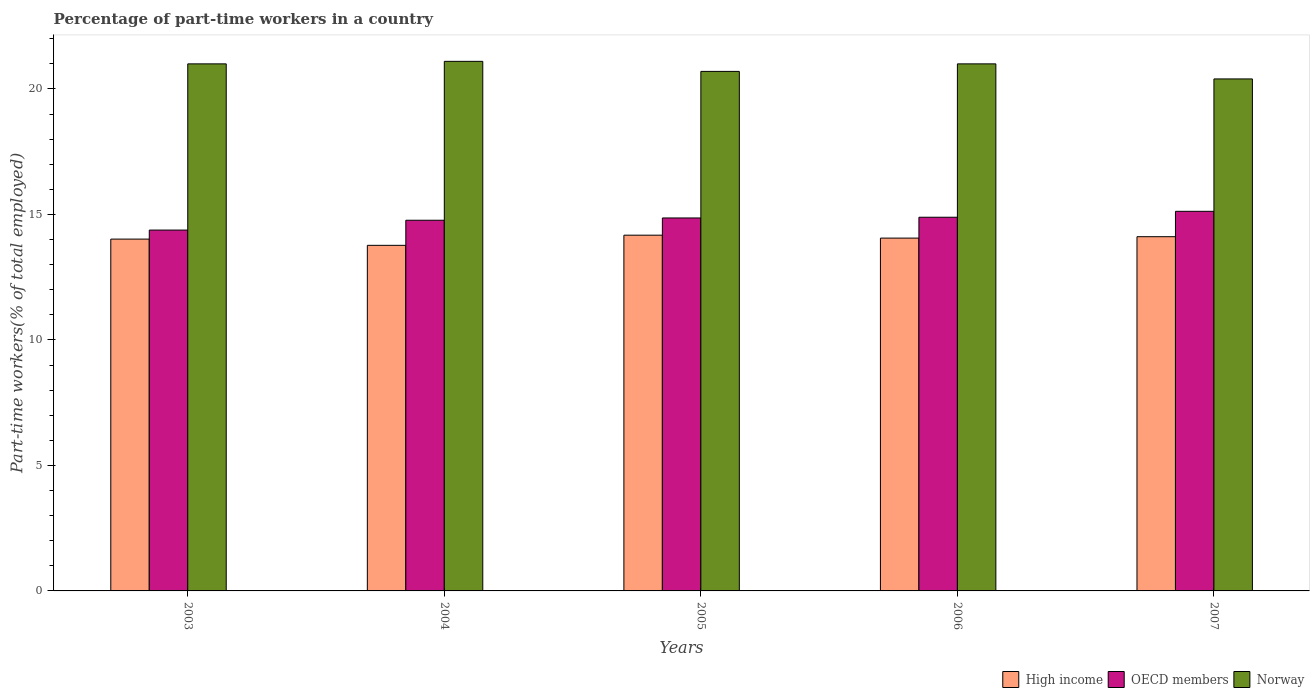How many different coloured bars are there?
Provide a short and direct response. 3. Are the number of bars per tick equal to the number of legend labels?
Offer a terse response. Yes. How many bars are there on the 5th tick from the right?
Your response must be concise. 3. What is the label of the 4th group of bars from the left?
Your response must be concise. 2006. Across all years, what is the maximum percentage of part-time workers in Norway?
Offer a very short reply. 21.1. Across all years, what is the minimum percentage of part-time workers in Norway?
Provide a short and direct response. 20.4. In which year was the percentage of part-time workers in Norway maximum?
Offer a very short reply. 2004. In which year was the percentage of part-time workers in Norway minimum?
Offer a terse response. 2007. What is the total percentage of part-time workers in Norway in the graph?
Offer a very short reply. 104.2. What is the difference between the percentage of part-time workers in Norway in 2005 and that in 2007?
Ensure brevity in your answer.  0.3. What is the difference between the percentage of part-time workers in High income in 2006 and the percentage of part-time workers in OECD members in 2004?
Provide a short and direct response. -0.71. What is the average percentage of part-time workers in High income per year?
Provide a succinct answer. 14.03. In the year 2007, what is the difference between the percentage of part-time workers in Norway and percentage of part-time workers in High income?
Your response must be concise. 6.29. What is the ratio of the percentage of part-time workers in High income in 2003 to that in 2007?
Provide a succinct answer. 0.99. Is the percentage of part-time workers in Norway in 2004 less than that in 2006?
Your response must be concise. No. What is the difference between the highest and the second highest percentage of part-time workers in OECD members?
Make the answer very short. 0.24. What is the difference between the highest and the lowest percentage of part-time workers in OECD members?
Offer a very short reply. 0.75. In how many years, is the percentage of part-time workers in OECD members greater than the average percentage of part-time workers in OECD members taken over all years?
Give a very brief answer. 3. Is the sum of the percentage of part-time workers in Norway in 2005 and 2007 greater than the maximum percentage of part-time workers in OECD members across all years?
Make the answer very short. Yes. What does the 2nd bar from the left in 2006 represents?
Your response must be concise. OECD members. Are all the bars in the graph horizontal?
Your answer should be very brief. No. How many years are there in the graph?
Provide a succinct answer. 5. Are the values on the major ticks of Y-axis written in scientific E-notation?
Your answer should be very brief. No. Does the graph contain grids?
Give a very brief answer. No. Where does the legend appear in the graph?
Give a very brief answer. Bottom right. How many legend labels are there?
Offer a terse response. 3. How are the legend labels stacked?
Give a very brief answer. Horizontal. What is the title of the graph?
Make the answer very short. Percentage of part-time workers in a country. Does "Hong Kong" appear as one of the legend labels in the graph?
Ensure brevity in your answer.  No. What is the label or title of the X-axis?
Offer a terse response. Years. What is the label or title of the Y-axis?
Give a very brief answer. Part-time workers(% of total employed). What is the Part-time workers(% of total employed) in High income in 2003?
Your answer should be compact. 14.02. What is the Part-time workers(% of total employed) of OECD members in 2003?
Provide a short and direct response. 14.38. What is the Part-time workers(% of total employed) in Norway in 2003?
Your response must be concise. 21. What is the Part-time workers(% of total employed) of High income in 2004?
Give a very brief answer. 13.77. What is the Part-time workers(% of total employed) of OECD members in 2004?
Ensure brevity in your answer.  14.77. What is the Part-time workers(% of total employed) of Norway in 2004?
Your answer should be compact. 21.1. What is the Part-time workers(% of total employed) of High income in 2005?
Your response must be concise. 14.17. What is the Part-time workers(% of total employed) of OECD members in 2005?
Keep it short and to the point. 14.86. What is the Part-time workers(% of total employed) of Norway in 2005?
Ensure brevity in your answer.  20.7. What is the Part-time workers(% of total employed) of High income in 2006?
Ensure brevity in your answer.  14.06. What is the Part-time workers(% of total employed) in OECD members in 2006?
Make the answer very short. 14.89. What is the Part-time workers(% of total employed) in Norway in 2006?
Ensure brevity in your answer.  21. What is the Part-time workers(% of total employed) of High income in 2007?
Your response must be concise. 14.11. What is the Part-time workers(% of total employed) in OECD members in 2007?
Your answer should be compact. 15.12. What is the Part-time workers(% of total employed) in Norway in 2007?
Give a very brief answer. 20.4. Across all years, what is the maximum Part-time workers(% of total employed) of High income?
Provide a short and direct response. 14.17. Across all years, what is the maximum Part-time workers(% of total employed) in OECD members?
Offer a terse response. 15.12. Across all years, what is the maximum Part-time workers(% of total employed) of Norway?
Keep it short and to the point. 21.1. Across all years, what is the minimum Part-time workers(% of total employed) in High income?
Provide a succinct answer. 13.77. Across all years, what is the minimum Part-time workers(% of total employed) in OECD members?
Provide a succinct answer. 14.38. Across all years, what is the minimum Part-time workers(% of total employed) in Norway?
Ensure brevity in your answer.  20.4. What is the total Part-time workers(% of total employed) of High income in the graph?
Provide a succinct answer. 70.13. What is the total Part-time workers(% of total employed) of OECD members in the graph?
Your answer should be compact. 74.02. What is the total Part-time workers(% of total employed) in Norway in the graph?
Offer a very short reply. 104.2. What is the difference between the Part-time workers(% of total employed) in High income in 2003 and that in 2004?
Make the answer very short. 0.25. What is the difference between the Part-time workers(% of total employed) in OECD members in 2003 and that in 2004?
Give a very brief answer. -0.39. What is the difference between the Part-time workers(% of total employed) in Norway in 2003 and that in 2004?
Make the answer very short. -0.1. What is the difference between the Part-time workers(% of total employed) of High income in 2003 and that in 2005?
Ensure brevity in your answer.  -0.16. What is the difference between the Part-time workers(% of total employed) in OECD members in 2003 and that in 2005?
Make the answer very short. -0.48. What is the difference between the Part-time workers(% of total employed) in Norway in 2003 and that in 2005?
Your answer should be compact. 0.3. What is the difference between the Part-time workers(% of total employed) of High income in 2003 and that in 2006?
Keep it short and to the point. -0.04. What is the difference between the Part-time workers(% of total employed) of OECD members in 2003 and that in 2006?
Keep it short and to the point. -0.51. What is the difference between the Part-time workers(% of total employed) of Norway in 2003 and that in 2006?
Offer a very short reply. 0. What is the difference between the Part-time workers(% of total employed) of High income in 2003 and that in 2007?
Keep it short and to the point. -0.1. What is the difference between the Part-time workers(% of total employed) of OECD members in 2003 and that in 2007?
Ensure brevity in your answer.  -0.75. What is the difference between the Part-time workers(% of total employed) in Norway in 2003 and that in 2007?
Your answer should be compact. 0.6. What is the difference between the Part-time workers(% of total employed) in High income in 2004 and that in 2005?
Keep it short and to the point. -0.4. What is the difference between the Part-time workers(% of total employed) in OECD members in 2004 and that in 2005?
Your answer should be very brief. -0.09. What is the difference between the Part-time workers(% of total employed) in Norway in 2004 and that in 2005?
Ensure brevity in your answer.  0.4. What is the difference between the Part-time workers(% of total employed) in High income in 2004 and that in 2006?
Keep it short and to the point. -0.29. What is the difference between the Part-time workers(% of total employed) in OECD members in 2004 and that in 2006?
Your response must be concise. -0.12. What is the difference between the Part-time workers(% of total employed) of High income in 2004 and that in 2007?
Your response must be concise. -0.34. What is the difference between the Part-time workers(% of total employed) in OECD members in 2004 and that in 2007?
Provide a short and direct response. -0.36. What is the difference between the Part-time workers(% of total employed) of High income in 2005 and that in 2006?
Make the answer very short. 0.12. What is the difference between the Part-time workers(% of total employed) in OECD members in 2005 and that in 2006?
Make the answer very short. -0.03. What is the difference between the Part-time workers(% of total employed) of Norway in 2005 and that in 2006?
Your answer should be compact. -0.3. What is the difference between the Part-time workers(% of total employed) of High income in 2005 and that in 2007?
Ensure brevity in your answer.  0.06. What is the difference between the Part-time workers(% of total employed) of OECD members in 2005 and that in 2007?
Your response must be concise. -0.26. What is the difference between the Part-time workers(% of total employed) in Norway in 2005 and that in 2007?
Offer a very short reply. 0.3. What is the difference between the Part-time workers(% of total employed) of High income in 2006 and that in 2007?
Make the answer very short. -0.06. What is the difference between the Part-time workers(% of total employed) of OECD members in 2006 and that in 2007?
Make the answer very short. -0.24. What is the difference between the Part-time workers(% of total employed) in Norway in 2006 and that in 2007?
Offer a terse response. 0.6. What is the difference between the Part-time workers(% of total employed) of High income in 2003 and the Part-time workers(% of total employed) of OECD members in 2004?
Offer a very short reply. -0.75. What is the difference between the Part-time workers(% of total employed) of High income in 2003 and the Part-time workers(% of total employed) of Norway in 2004?
Your answer should be very brief. -7.08. What is the difference between the Part-time workers(% of total employed) of OECD members in 2003 and the Part-time workers(% of total employed) of Norway in 2004?
Keep it short and to the point. -6.72. What is the difference between the Part-time workers(% of total employed) in High income in 2003 and the Part-time workers(% of total employed) in OECD members in 2005?
Make the answer very short. -0.84. What is the difference between the Part-time workers(% of total employed) in High income in 2003 and the Part-time workers(% of total employed) in Norway in 2005?
Give a very brief answer. -6.68. What is the difference between the Part-time workers(% of total employed) of OECD members in 2003 and the Part-time workers(% of total employed) of Norway in 2005?
Your answer should be very brief. -6.32. What is the difference between the Part-time workers(% of total employed) in High income in 2003 and the Part-time workers(% of total employed) in OECD members in 2006?
Your response must be concise. -0.87. What is the difference between the Part-time workers(% of total employed) in High income in 2003 and the Part-time workers(% of total employed) in Norway in 2006?
Your response must be concise. -6.98. What is the difference between the Part-time workers(% of total employed) in OECD members in 2003 and the Part-time workers(% of total employed) in Norway in 2006?
Your response must be concise. -6.62. What is the difference between the Part-time workers(% of total employed) of High income in 2003 and the Part-time workers(% of total employed) of OECD members in 2007?
Provide a short and direct response. -1.11. What is the difference between the Part-time workers(% of total employed) of High income in 2003 and the Part-time workers(% of total employed) of Norway in 2007?
Make the answer very short. -6.38. What is the difference between the Part-time workers(% of total employed) in OECD members in 2003 and the Part-time workers(% of total employed) in Norway in 2007?
Provide a succinct answer. -6.02. What is the difference between the Part-time workers(% of total employed) of High income in 2004 and the Part-time workers(% of total employed) of OECD members in 2005?
Keep it short and to the point. -1.09. What is the difference between the Part-time workers(% of total employed) in High income in 2004 and the Part-time workers(% of total employed) in Norway in 2005?
Keep it short and to the point. -6.93. What is the difference between the Part-time workers(% of total employed) of OECD members in 2004 and the Part-time workers(% of total employed) of Norway in 2005?
Provide a short and direct response. -5.93. What is the difference between the Part-time workers(% of total employed) of High income in 2004 and the Part-time workers(% of total employed) of OECD members in 2006?
Ensure brevity in your answer.  -1.12. What is the difference between the Part-time workers(% of total employed) of High income in 2004 and the Part-time workers(% of total employed) of Norway in 2006?
Ensure brevity in your answer.  -7.23. What is the difference between the Part-time workers(% of total employed) of OECD members in 2004 and the Part-time workers(% of total employed) of Norway in 2006?
Ensure brevity in your answer.  -6.23. What is the difference between the Part-time workers(% of total employed) in High income in 2004 and the Part-time workers(% of total employed) in OECD members in 2007?
Keep it short and to the point. -1.36. What is the difference between the Part-time workers(% of total employed) in High income in 2004 and the Part-time workers(% of total employed) in Norway in 2007?
Your response must be concise. -6.63. What is the difference between the Part-time workers(% of total employed) in OECD members in 2004 and the Part-time workers(% of total employed) in Norway in 2007?
Provide a succinct answer. -5.63. What is the difference between the Part-time workers(% of total employed) in High income in 2005 and the Part-time workers(% of total employed) in OECD members in 2006?
Make the answer very short. -0.71. What is the difference between the Part-time workers(% of total employed) of High income in 2005 and the Part-time workers(% of total employed) of Norway in 2006?
Offer a very short reply. -6.83. What is the difference between the Part-time workers(% of total employed) in OECD members in 2005 and the Part-time workers(% of total employed) in Norway in 2006?
Make the answer very short. -6.14. What is the difference between the Part-time workers(% of total employed) of High income in 2005 and the Part-time workers(% of total employed) of OECD members in 2007?
Offer a very short reply. -0.95. What is the difference between the Part-time workers(% of total employed) in High income in 2005 and the Part-time workers(% of total employed) in Norway in 2007?
Provide a short and direct response. -6.23. What is the difference between the Part-time workers(% of total employed) of OECD members in 2005 and the Part-time workers(% of total employed) of Norway in 2007?
Make the answer very short. -5.54. What is the difference between the Part-time workers(% of total employed) in High income in 2006 and the Part-time workers(% of total employed) in OECD members in 2007?
Your response must be concise. -1.07. What is the difference between the Part-time workers(% of total employed) of High income in 2006 and the Part-time workers(% of total employed) of Norway in 2007?
Make the answer very short. -6.34. What is the difference between the Part-time workers(% of total employed) of OECD members in 2006 and the Part-time workers(% of total employed) of Norway in 2007?
Keep it short and to the point. -5.51. What is the average Part-time workers(% of total employed) of High income per year?
Your answer should be very brief. 14.03. What is the average Part-time workers(% of total employed) in OECD members per year?
Your answer should be very brief. 14.8. What is the average Part-time workers(% of total employed) in Norway per year?
Your answer should be compact. 20.84. In the year 2003, what is the difference between the Part-time workers(% of total employed) of High income and Part-time workers(% of total employed) of OECD members?
Ensure brevity in your answer.  -0.36. In the year 2003, what is the difference between the Part-time workers(% of total employed) in High income and Part-time workers(% of total employed) in Norway?
Keep it short and to the point. -6.98. In the year 2003, what is the difference between the Part-time workers(% of total employed) in OECD members and Part-time workers(% of total employed) in Norway?
Keep it short and to the point. -6.62. In the year 2004, what is the difference between the Part-time workers(% of total employed) in High income and Part-time workers(% of total employed) in OECD members?
Your response must be concise. -1. In the year 2004, what is the difference between the Part-time workers(% of total employed) in High income and Part-time workers(% of total employed) in Norway?
Provide a short and direct response. -7.33. In the year 2004, what is the difference between the Part-time workers(% of total employed) in OECD members and Part-time workers(% of total employed) in Norway?
Your answer should be very brief. -6.33. In the year 2005, what is the difference between the Part-time workers(% of total employed) in High income and Part-time workers(% of total employed) in OECD members?
Your response must be concise. -0.69. In the year 2005, what is the difference between the Part-time workers(% of total employed) in High income and Part-time workers(% of total employed) in Norway?
Make the answer very short. -6.53. In the year 2005, what is the difference between the Part-time workers(% of total employed) in OECD members and Part-time workers(% of total employed) in Norway?
Keep it short and to the point. -5.84. In the year 2006, what is the difference between the Part-time workers(% of total employed) in High income and Part-time workers(% of total employed) in OECD members?
Your answer should be compact. -0.83. In the year 2006, what is the difference between the Part-time workers(% of total employed) in High income and Part-time workers(% of total employed) in Norway?
Ensure brevity in your answer.  -6.94. In the year 2006, what is the difference between the Part-time workers(% of total employed) of OECD members and Part-time workers(% of total employed) of Norway?
Your answer should be very brief. -6.11. In the year 2007, what is the difference between the Part-time workers(% of total employed) of High income and Part-time workers(% of total employed) of OECD members?
Offer a very short reply. -1.01. In the year 2007, what is the difference between the Part-time workers(% of total employed) of High income and Part-time workers(% of total employed) of Norway?
Ensure brevity in your answer.  -6.29. In the year 2007, what is the difference between the Part-time workers(% of total employed) of OECD members and Part-time workers(% of total employed) of Norway?
Your answer should be compact. -5.28. What is the ratio of the Part-time workers(% of total employed) in OECD members in 2003 to that in 2004?
Offer a very short reply. 0.97. What is the ratio of the Part-time workers(% of total employed) of High income in 2003 to that in 2005?
Make the answer very short. 0.99. What is the ratio of the Part-time workers(% of total employed) of OECD members in 2003 to that in 2005?
Your answer should be compact. 0.97. What is the ratio of the Part-time workers(% of total employed) in Norway in 2003 to that in 2005?
Your answer should be very brief. 1.01. What is the ratio of the Part-time workers(% of total employed) of High income in 2003 to that in 2006?
Offer a terse response. 1. What is the ratio of the Part-time workers(% of total employed) in OECD members in 2003 to that in 2006?
Give a very brief answer. 0.97. What is the ratio of the Part-time workers(% of total employed) in OECD members in 2003 to that in 2007?
Offer a terse response. 0.95. What is the ratio of the Part-time workers(% of total employed) in Norway in 2003 to that in 2007?
Give a very brief answer. 1.03. What is the ratio of the Part-time workers(% of total employed) in High income in 2004 to that in 2005?
Offer a terse response. 0.97. What is the ratio of the Part-time workers(% of total employed) of OECD members in 2004 to that in 2005?
Provide a succinct answer. 0.99. What is the ratio of the Part-time workers(% of total employed) of Norway in 2004 to that in 2005?
Offer a very short reply. 1.02. What is the ratio of the Part-time workers(% of total employed) of High income in 2004 to that in 2006?
Give a very brief answer. 0.98. What is the ratio of the Part-time workers(% of total employed) in Norway in 2004 to that in 2006?
Ensure brevity in your answer.  1. What is the ratio of the Part-time workers(% of total employed) of High income in 2004 to that in 2007?
Make the answer very short. 0.98. What is the ratio of the Part-time workers(% of total employed) in OECD members in 2004 to that in 2007?
Provide a succinct answer. 0.98. What is the ratio of the Part-time workers(% of total employed) of Norway in 2004 to that in 2007?
Provide a short and direct response. 1.03. What is the ratio of the Part-time workers(% of total employed) of High income in 2005 to that in 2006?
Your answer should be compact. 1.01. What is the ratio of the Part-time workers(% of total employed) of Norway in 2005 to that in 2006?
Your response must be concise. 0.99. What is the ratio of the Part-time workers(% of total employed) in OECD members in 2005 to that in 2007?
Your answer should be compact. 0.98. What is the ratio of the Part-time workers(% of total employed) of Norway in 2005 to that in 2007?
Make the answer very short. 1.01. What is the ratio of the Part-time workers(% of total employed) in OECD members in 2006 to that in 2007?
Keep it short and to the point. 0.98. What is the ratio of the Part-time workers(% of total employed) of Norway in 2006 to that in 2007?
Ensure brevity in your answer.  1.03. What is the difference between the highest and the second highest Part-time workers(% of total employed) of High income?
Offer a terse response. 0.06. What is the difference between the highest and the second highest Part-time workers(% of total employed) in OECD members?
Give a very brief answer. 0.24. What is the difference between the highest and the lowest Part-time workers(% of total employed) in High income?
Offer a terse response. 0.4. What is the difference between the highest and the lowest Part-time workers(% of total employed) of OECD members?
Give a very brief answer. 0.75. 